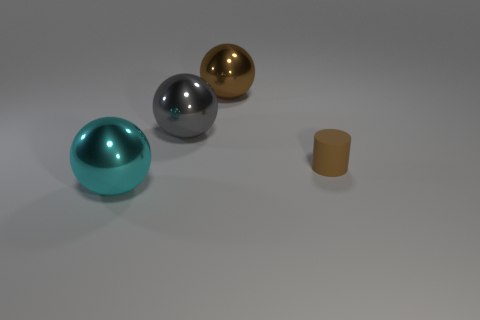Add 3 large brown things. How many objects exist? 7 Subtract all large cyan shiny spheres. How many spheres are left? 2 Subtract all brown balls. How many balls are left? 2 Subtract 1 cylinders. How many cylinders are left? 0 Subtract all purple cylinders. Subtract all blue balls. How many cylinders are left? 1 Subtract all cyan cylinders. How many cyan spheres are left? 1 Subtract all small purple metal balls. Subtract all large cyan balls. How many objects are left? 3 Add 1 cyan metallic things. How many cyan metallic things are left? 2 Add 1 large blue spheres. How many large blue spheres exist? 1 Subtract 0 cyan cylinders. How many objects are left? 4 